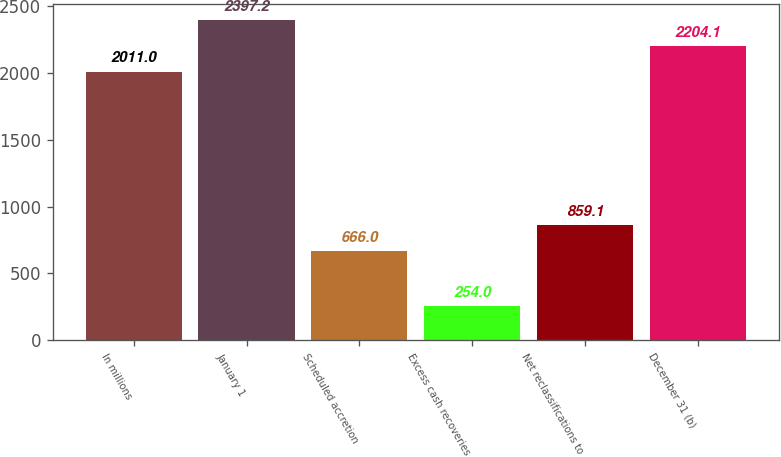Convert chart to OTSL. <chart><loc_0><loc_0><loc_500><loc_500><bar_chart><fcel>In millions<fcel>January 1<fcel>Scheduled accretion<fcel>Excess cash recoveries<fcel>Net reclassifications to<fcel>December 31 (b)<nl><fcel>2011<fcel>2397.2<fcel>666<fcel>254<fcel>859.1<fcel>2204.1<nl></chart> 